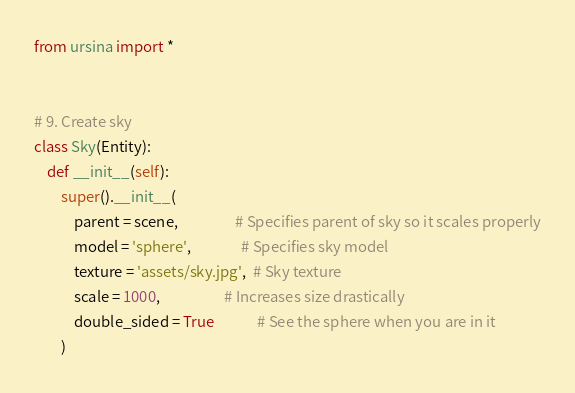<code> <loc_0><loc_0><loc_500><loc_500><_Python_>from ursina import *


# 9. Create sky
class Sky(Entity):
    def __init__(self):
        super().__init__(
            parent = scene,                 # Specifies parent of sky so it scales properly
            model = 'sphere',               # Specifies sky model
            texture = 'assets/sky.jpg',  # Sky texture
            scale = 1000,                   # Increases size drastically
            double_sided = True             # See the sphere when you are in it
        )</code> 